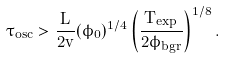Convert formula to latex. <formula><loc_0><loc_0><loc_500><loc_500>\tau _ { o s c } > \frac { L } { 2 v } ( \phi _ { 0 } ) ^ { 1 / 4 } \left ( \frac { T _ { e x p } } { 2 \phi _ { b g r } } \right ) ^ { 1 / 8 } .</formula> 